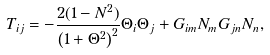Convert formula to latex. <formula><loc_0><loc_0><loc_500><loc_500>T _ { i j } = - \frac { 2 ( 1 - N ^ { 2 } ) } { \left ( 1 + \Theta ^ { 2 } \right ) ^ { 2 } } \Theta _ { i } \Theta _ { j } + G _ { i m } N _ { m } G _ { j n } N _ { n } ,</formula> 